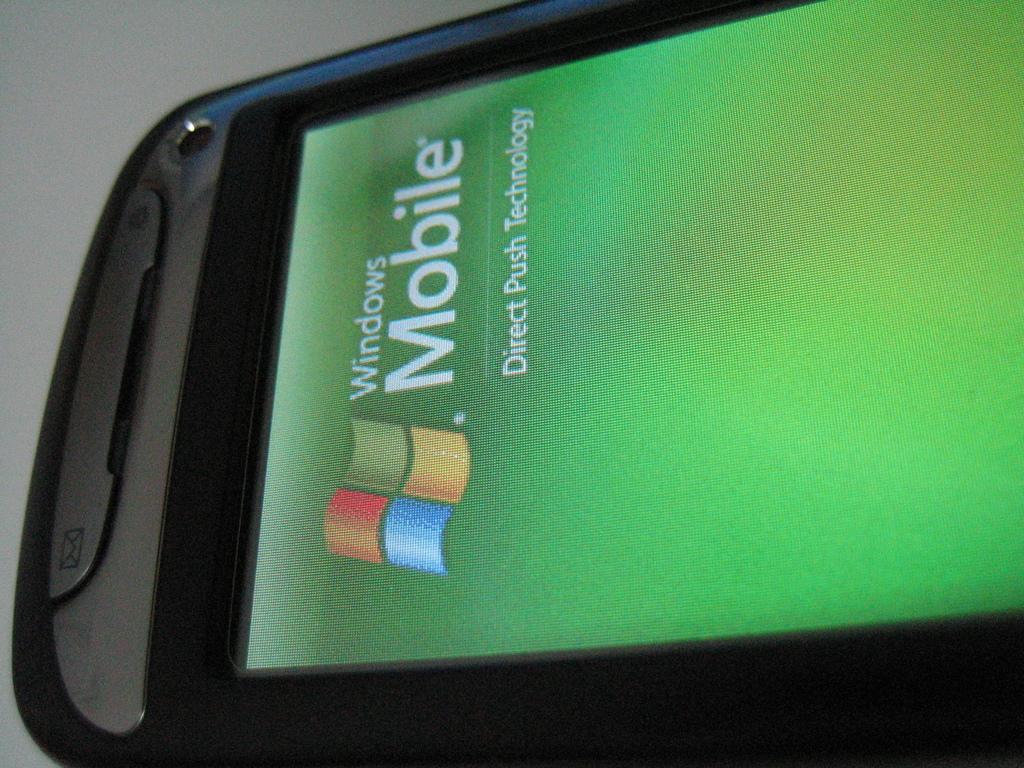What operating system is on this phone?
Ensure brevity in your answer.  Windows. What kind of technology does this phone feature?
Offer a very short reply. Direct push technology. 